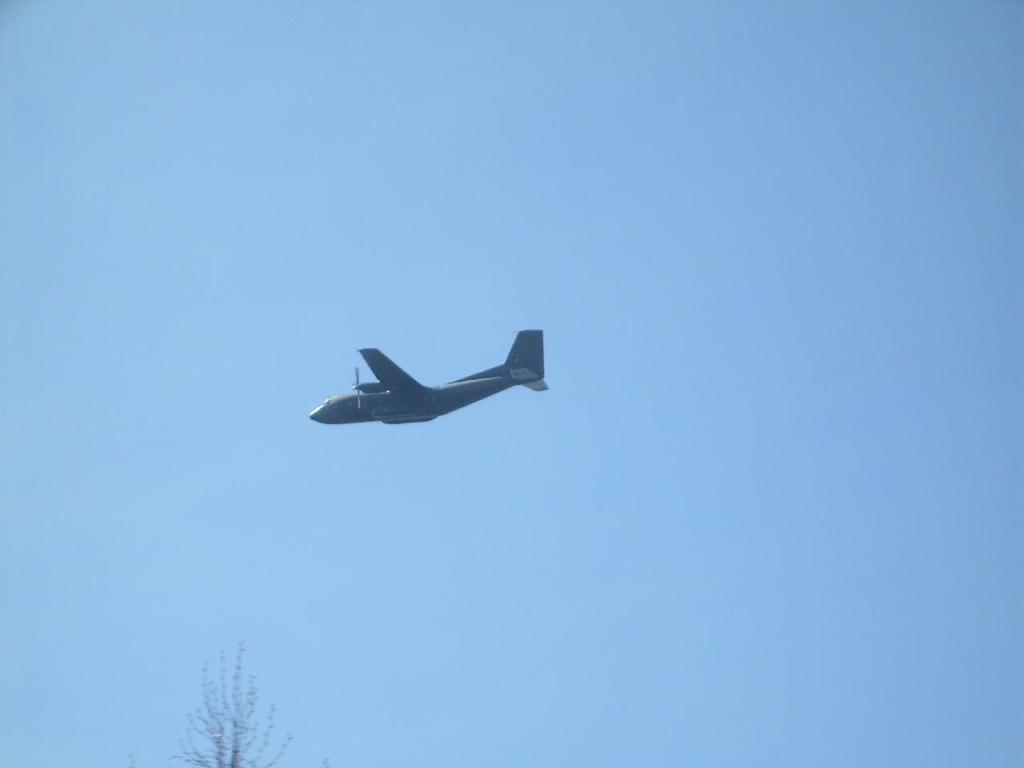What is the main subject of the image? The main subject of the image is a plane in the air. Where is the plane located in the image? The plane is in the middle of the image. What can be seen in the background of the image? There is a blue sky and a tree in the background of the image. What type of attraction is the plane promoting in the image? There is no indication in the image that the plane is promoting any attraction. What is the secretary's role in the image? There is no secretary present in the image. 